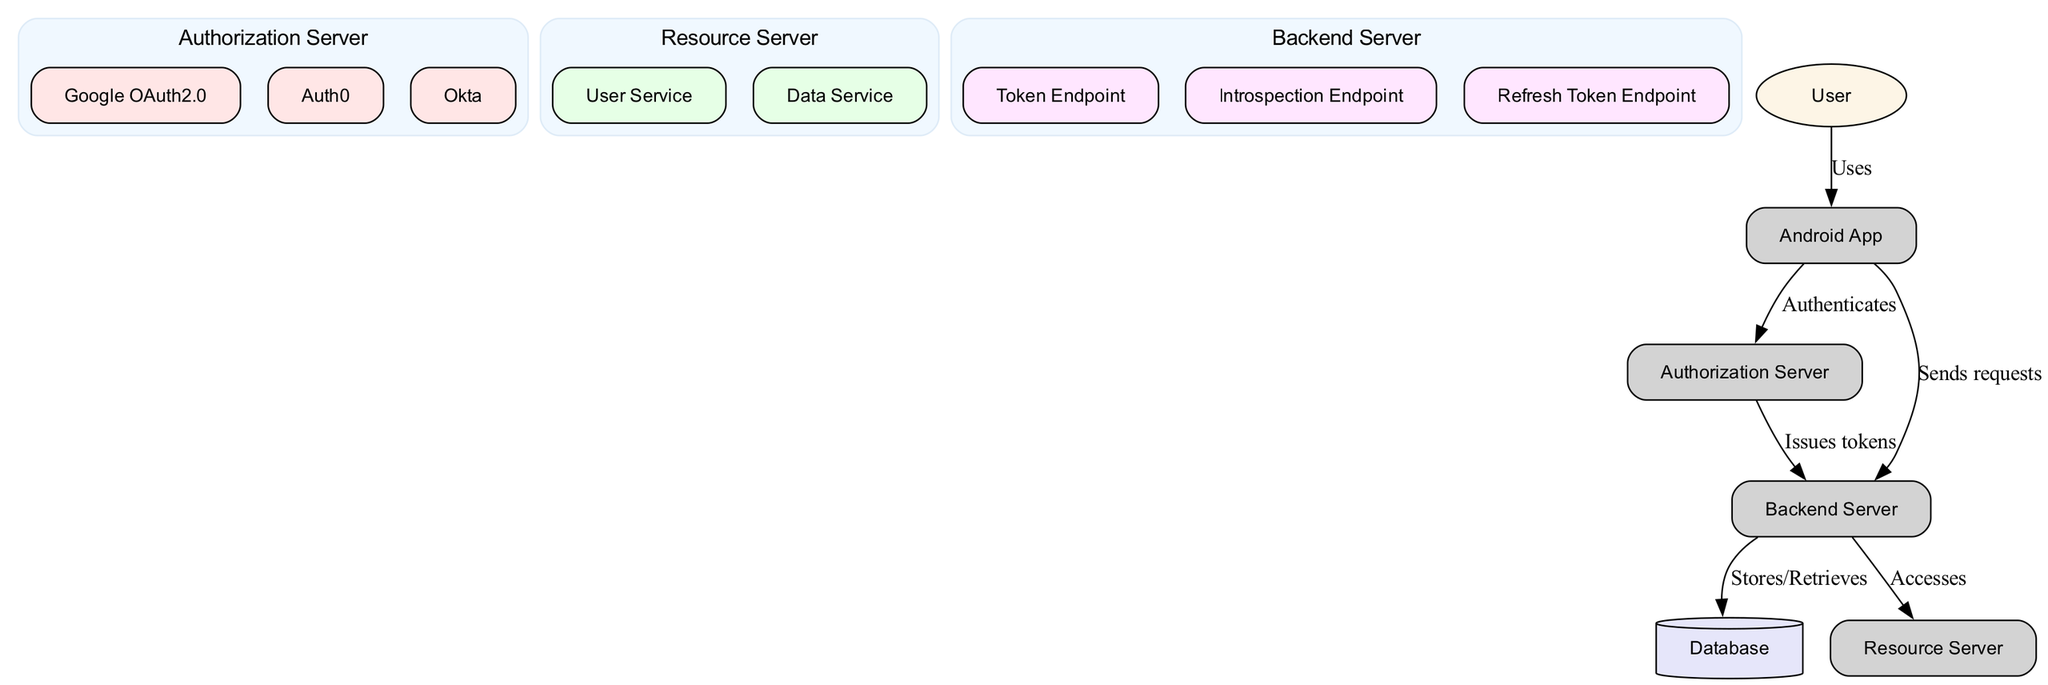What is the main role of the Android App in this flow? The Android App initiates the OAuth2 authentication request and interacts with the OAuth2 flow, serving as the client that connects to the authorization server.
Answer: Initiates the authentication request How many servers are depicted in the diagram? The diagram lists three server types: Authorization Server, Resource Server, and Backend Server, making a total of three servers.
Answer: Three Which server issues tokens? The Authorization Server is responsible for handling the authentication process and issuing tokens as part of the OAuth2 flow.
Answer: Authorization Server What does the backend server access in this diagram? The Backend Server accesses the Resource Server to retrieve or manipulate data required by the application.
Answer: Resource Server What type of storage is used for credentials and tokens? The database is depicted as the storage type that holds user credentials and token information in the diagram.
Answer: Database How does the Android App communicate with the Authorization Server? The Android App communicates with the Authorization Server by sending an authentication request as part of the OAuth2 protocol flow.
Answer: Authenticates What types of endpoints are included in the Backend Server? The Backend Server contains three endpoint types: Token Endpoint, Introspection Endpoint, and Refresh Token Endpoint to handle different aspects of token management.
Answer: Token Endpoint, Introspection Endpoint, Refresh Token Endpoint Who is the primary user interacting with the Android App? The User is the end-user who initiates the OAuth2 flow by utilizing the Android App for authentication purposes.
Answer: User What is the function of the User Service in the Resource Server? The User Service in the Resource Server manages operations related to the user, such as user data or account details management.
Answer: Manages user-related operations 